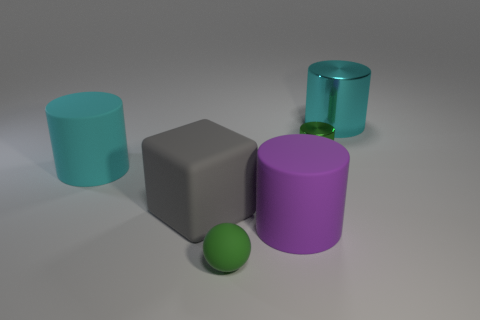Add 2 metallic cylinders. How many objects exist? 8 Subtract all red cylinders. Subtract all cyan blocks. How many cylinders are left? 4 Subtract all spheres. How many objects are left? 5 Add 3 large cubes. How many large cubes exist? 4 Subtract 0 cyan cubes. How many objects are left? 6 Subtract all purple metal cylinders. Subtract all small green shiny cylinders. How many objects are left? 5 Add 3 cubes. How many cubes are left? 4 